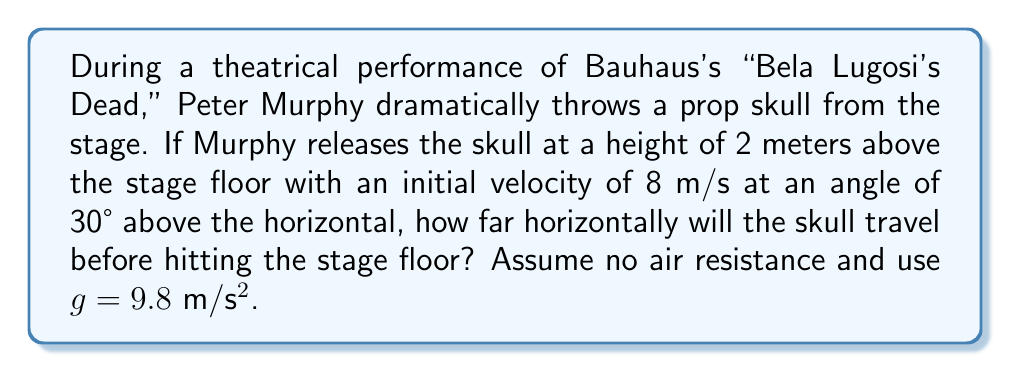Solve this math problem. To solve this problem, we'll use the equations of projectile motion. Let's break it down step by step:

1) First, let's identify the known variables:
   - Initial height, $h_0 = 2$ m
   - Initial velocity, $v_0 = 8$ m/s
   - Angle of projection, $\theta = 30°$
   - Acceleration due to gravity, $g = 9.8$ m/s²

2) We need to find the horizontal distance (range) the skull travels. We can use the equation:

   $$R = \frac{v_0^2 \sin(2\theta)}{g} + v_0 \cos(\theta) \sqrt{\frac{2h_0}{g} + \frac{v_0^2 \sin^2(\theta)}{g^2}}$$

3) Let's calculate the components we need:
   $\sin(30°) = 0.5$
   $\cos(30°) = \frac{\sqrt{3}}{2} \approx 0.866$
   $\sin(60°) = \frac{\sqrt{3}}{2} \approx 0.866$

4) Now, let's substitute these values into our equation:

   $$R = \frac{8^2 \cdot 0.866}{9.8} + 8 \cdot 0.866 \sqrt{\frac{2 \cdot 2}{9.8} + \frac{8^2 \cdot 0.5^2}{9.8^2}}$$

5) Let's solve the equation step by step:
   $$R = 5.65 + 6.93 \sqrt{0.408 + 0.167}$$
   $$R = 5.65 + 6.93 \sqrt{0.575}$$
   $$R = 5.65 + 6.93 \cdot 0.758$$
   $$R = 5.65 + 5.25$$
   $$R = 10.90$$

Therefore, the skull will travel approximately 10.90 meters horizontally before hitting the stage floor.
Answer: 10.90 meters 